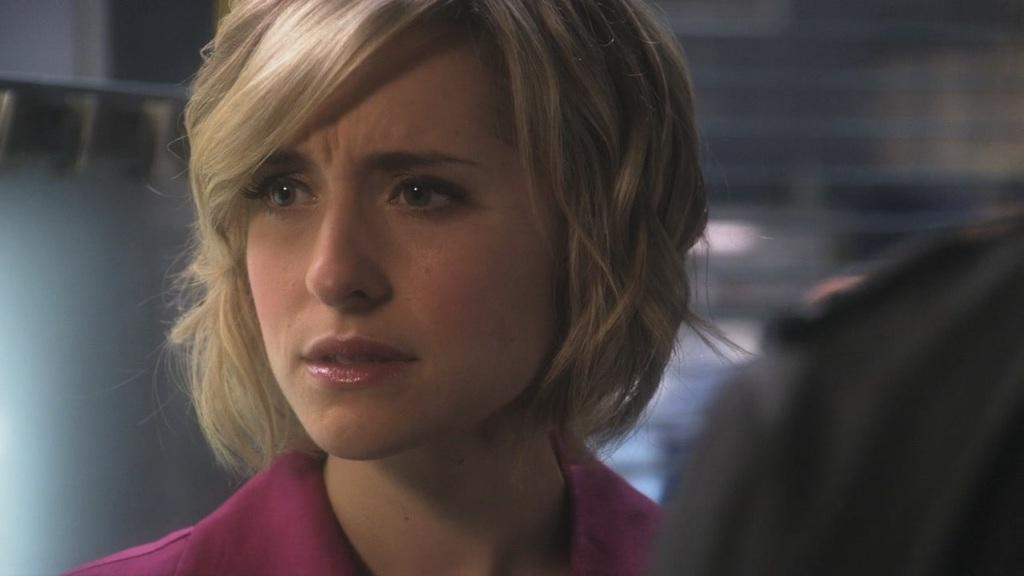Who is the main subject in the image? There is a woman in the image. What is the woman doing in the image? The woman is looking to the left. Can you describe the person on the right side of the image? There appears to be a person on the right side of the image. What is the background of the image like? The background of the image is blurred. What type of polish is the woman applying to her nails in the image? There is no indication in the image that the woman is applying polish to her nails. Can you tell me what type of drink the person on the right side of the image is holding? There is no person holding a drink in the image. 